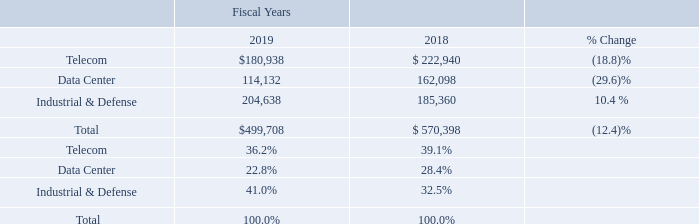Comparison of Fiscal Year Ended September 27, 2019 to Fiscal Year Ended September 28, 2018
Revenue. In fiscal year 2019, our revenue decreased by $70.7 million, or 12.4%, to $499.7 million from $570.4 million for fiscal year 2018. Revenue from our primary markets, the percentage of change between the years and revenue by primary markets expressed as a percentage of total revenue were (in thousands, except percentages):
In fiscal year 2019, our Telecom market revenue decreased by $42.0 million, or 18.8%, compared to fiscal year 2018. The decrease was primarily due to the full year effect of our May 2018 sale of the Japan-based long-range optical subassembly business (the "LR4 Business"), lower sales of carrier-based optical semiconductor products to our Asia customer base, as well as lower sales of products targeting fiber to the home applications.
In fiscal year 2019, our Data Center market revenue decreased by $48.0 million, or 29.6%, compared to fiscal year 2018. The decrease was primarily due to lower revenue related to sales of legacy optical products and lasers, partially offset by the recognition of $7.0 million of licensing revenue during the fiscal year ended September 27, 2019.
In fiscal year 2019, our I&D market revenues increased by $19.3 million, or 10.4%, compared to fiscal year 2018. The increase was related to higher revenue from sales across the product portfolio.
What led to I&D market revenues to increase in fiscal year 2019? Higher revenue from sales across the product portfolio. What is the change in Telecom value between fiscal year 2018 and 2019?
Answer scale should be: thousand. 180,938-222,940
Answer: -42002. What is the average Telecom for fiscal year 2018 and 2019?
Answer scale should be: thousand. (180,938+222,940) / 2
Answer: 201939. In which year was Telecom less than 200,000 thousand? Locate and analyze telecom in row 3
answer: 2019. What was the value of Data Center in 2019 and 2018 respectively?
Answer scale should be: thousand. 114,132, 162,098. What was the decrease in the revenue in 2019? $70.7 million. 